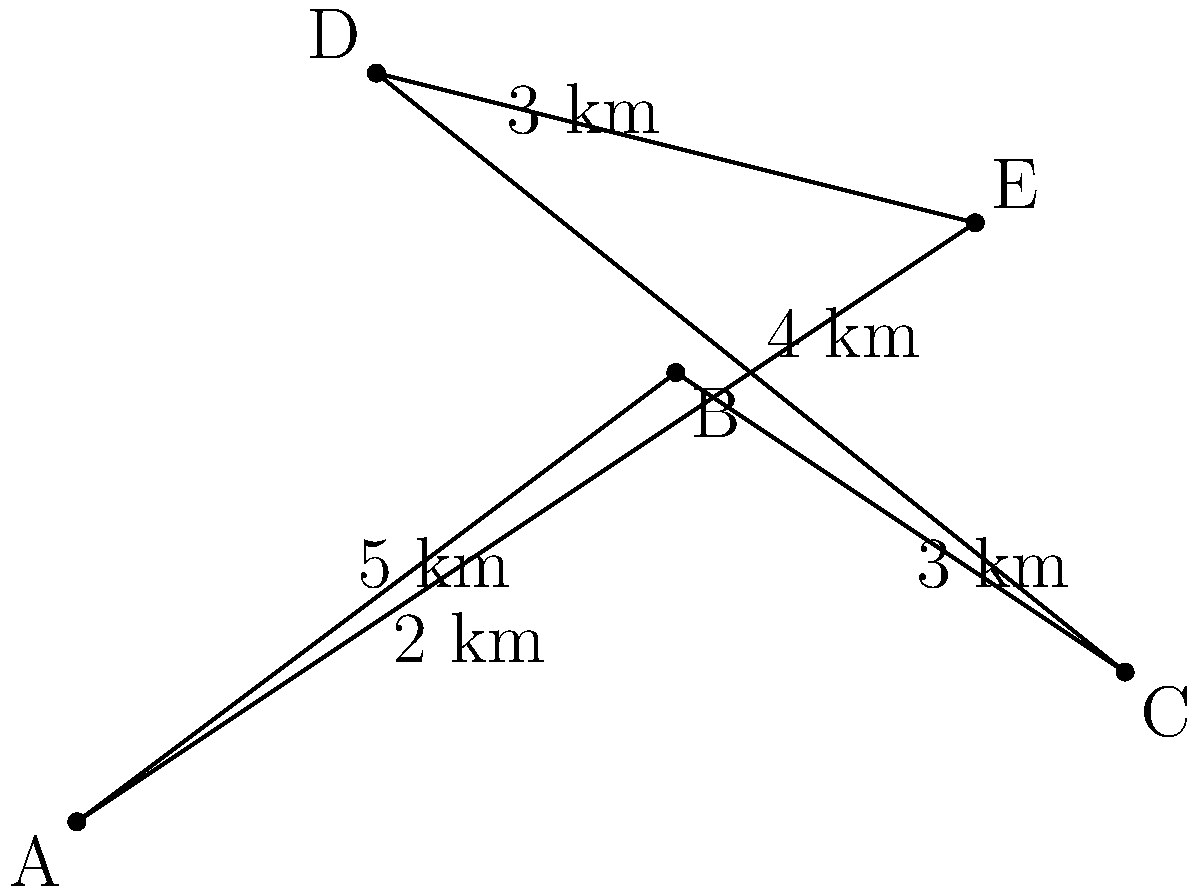Given the map of customer locations (A, B, C, D, E) and the distances between them, what is the shortest possible route that visits all customers exactly once and returns to the starting point? Provide the route order and total distance. To find the shortest route, we need to consider all possible permutations of the five locations and calculate the total distance for each. This is known as the Traveling Salesman Problem.

Step 1: List all possible routes (there are 24 in total due to 5! permutations, but we'll consider the route starting and ending at A).

Step 2: Calculate the distance for each route. For example:
A-B-C-D-E-A = 2 + 3 + 4 + 3 + 5 = 17 km
A-B-C-E-D-A = 2 + 3 + 5 + 3 + 4 = 17 km
A-B-D-C-E-A = 2 + 5 + 4 + 5 + 5 = 21 km
...

Step 3: Compare all route distances and identify the shortest one.

After calculating all routes, we find that the shortest route is:
A-B-C-E-D-A

Step 4: Calculate the total distance of the shortest route:
A to B: 2 km
B to C: 3 km
C to E: 5 km
E to D: 3 km
D to A: 4 km

Total distance = 2 + 3 + 5 + 3 + 4 = 17 km
Answer: A-B-C-E-D-A, 17 km 